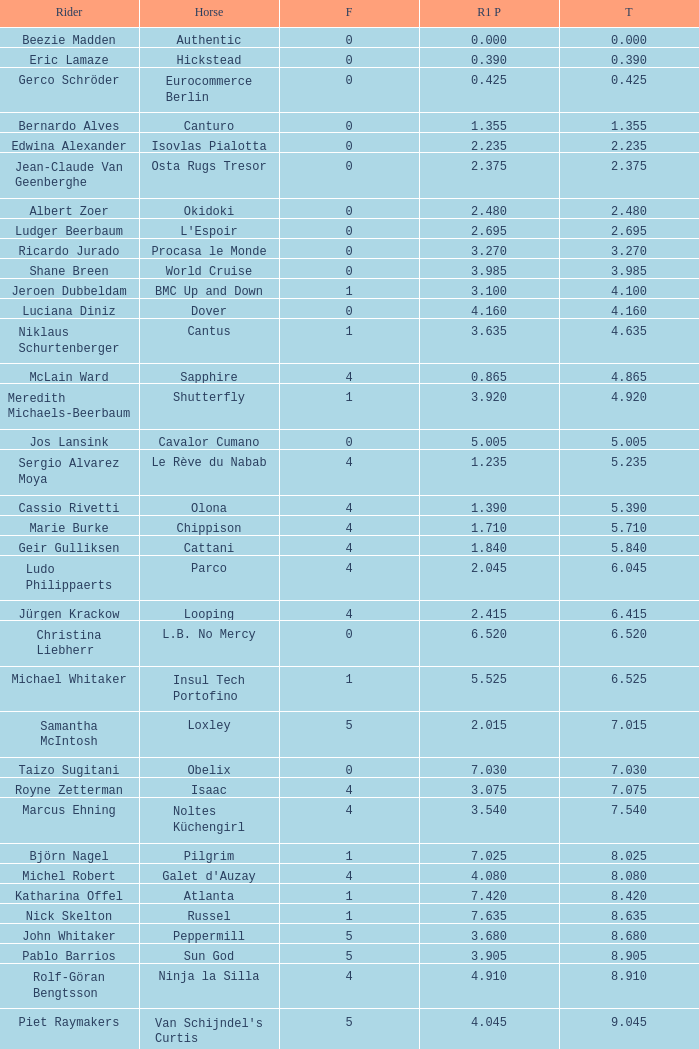Tell me the rider that had round 1 points of 7.465 and total more than 16.615 Manuel Fernandez Saro. 